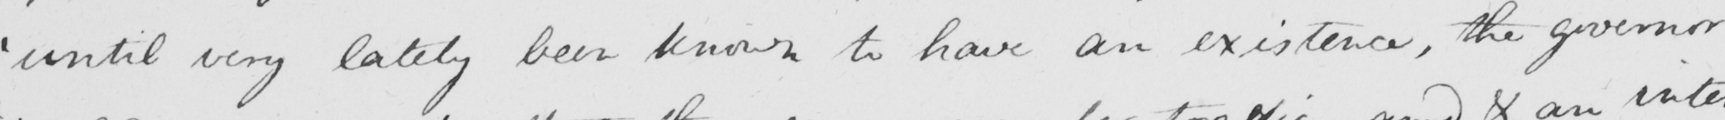Please provide the text content of this handwritten line. ' until very lately been known to have an existence , the governor 